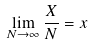Convert formula to latex. <formula><loc_0><loc_0><loc_500><loc_500>\lim _ { N \to \infty } \frac { X } { N } = x</formula> 